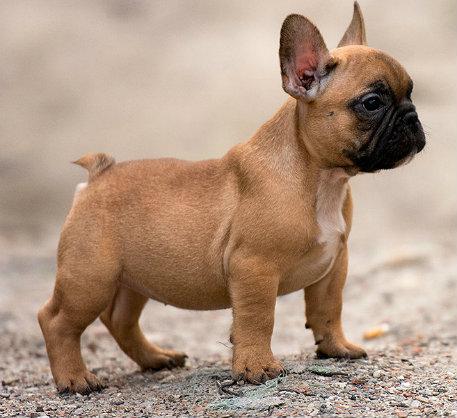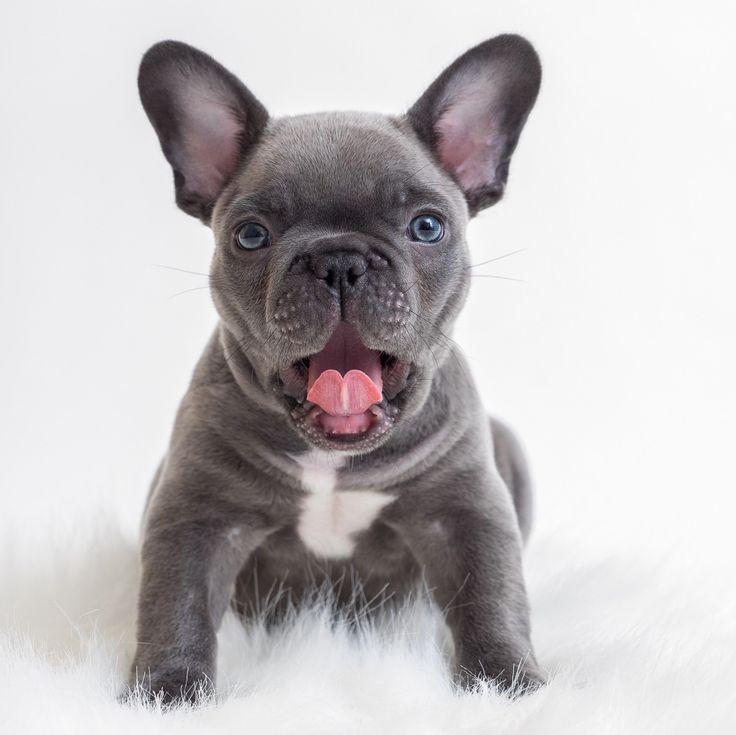The first image is the image on the left, the second image is the image on the right. Evaluate the accuracy of this statement regarding the images: "In the left image, a french bull dog puppy is standing and facing toward the right". Is it true? Answer yes or no. Yes. 